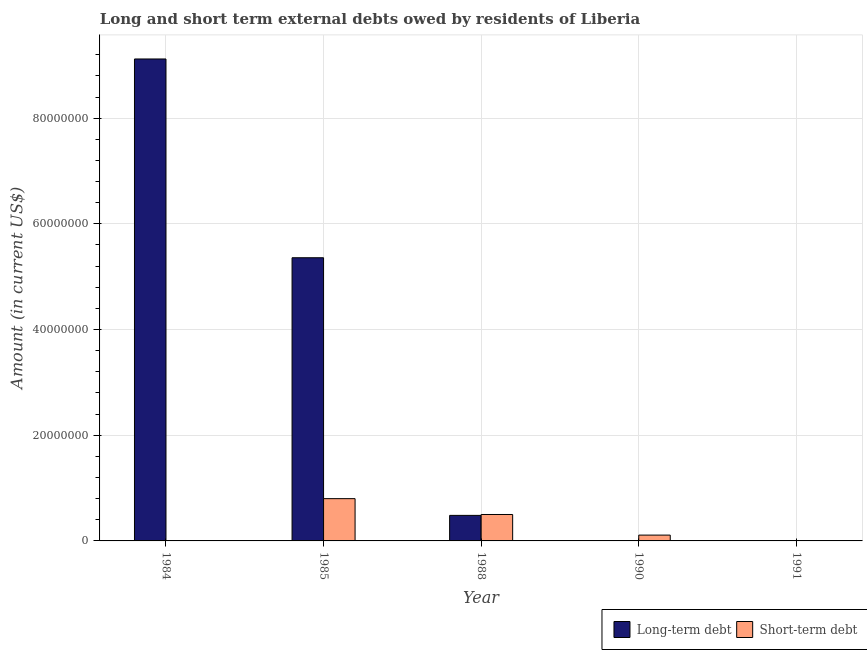How many different coloured bars are there?
Provide a succinct answer. 2. Are the number of bars per tick equal to the number of legend labels?
Keep it short and to the point. No. Are the number of bars on each tick of the X-axis equal?
Offer a very short reply. No. How many bars are there on the 3rd tick from the right?
Your response must be concise. 2. What is the label of the 3rd group of bars from the left?
Your response must be concise. 1988. What is the long-term debts owed by residents in 1984?
Ensure brevity in your answer.  9.12e+07. Across all years, what is the maximum long-term debts owed by residents?
Ensure brevity in your answer.  9.12e+07. Across all years, what is the minimum short-term debts owed by residents?
Ensure brevity in your answer.  0. In which year was the short-term debts owed by residents maximum?
Your answer should be compact. 1985. What is the total long-term debts owed by residents in the graph?
Make the answer very short. 1.50e+08. What is the difference between the long-term debts owed by residents in 1984 and that in 1988?
Provide a short and direct response. 8.64e+07. What is the difference between the long-term debts owed by residents in 1990 and the short-term debts owed by residents in 1991?
Ensure brevity in your answer.  0. What is the average long-term debts owed by residents per year?
Ensure brevity in your answer.  2.99e+07. In the year 1985, what is the difference between the short-term debts owed by residents and long-term debts owed by residents?
Offer a very short reply. 0. What is the ratio of the long-term debts owed by residents in 1984 to that in 1988?
Keep it short and to the point. 18.87. Is the short-term debts owed by residents in 1985 less than that in 1990?
Make the answer very short. No. Is the difference between the long-term debts owed by residents in 1984 and 1988 greater than the difference between the short-term debts owed by residents in 1984 and 1988?
Your answer should be very brief. No. What is the difference between the highest and the second highest long-term debts owed by residents?
Your answer should be compact. 3.76e+07. What is the difference between the highest and the lowest long-term debts owed by residents?
Make the answer very short. 9.12e+07. Is the sum of the short-term debts owed by residents in 1988 and 1990 greater than the maximum long-term debts owed by residents across all years?
Make the answer very short. No. Are all the bars in the graph horizontal?
Provide a short and direct response. No. Does the graph contain any zero values?
Your answer should be very brief. Yes. Where does the legend appear in the graph?
Offer a terse response. Bottom right. What is the title of the graph?
Give a very brief answer. Long and short term external debts owed by residents of Liberia. Does "From Government" appear as one of the legend labels in the graph?
Offer a very short reply. No. What is the label or title of the X-axis?
Ensure brevity in your answer.  Year. What is the label or title of the Y-axis?
Your response must be concise. Amount (in current US$). What is the Amount (in current US$) of Long-term debt in 1984?
Offer a terse response. 9.12e+07. What is the Amount (in current US$) of Long-term debt in 1985?
Offer a very short reply. 5.36e+07. What is the Amount (in current US$) of Short-term debt in 1985?
Your answer should be compact. 8.00e+06. What is the Amount (in current US$) in Long-term debt in 1988?
Your response must be concise. 4.83e+06. What is the Amount (in current US$) in Short-term debt in 1990?
Offer a very short reply. 1.10e+06. What is the Amount (in current US$) in Long-term debt in 1991?
Offer a very short reply. 0. What is the Amount (in current US$) in Short-term debt in 1991?
Ensure brevity in your answer.  0. Across all years, what is the maximum Amount (in current US$) in Long-term debt?
Offer a terse response. 9.12e+07. Across all years, what is the maximum Amount (in current US$) of Short-term debt?
Your response must be concise. 8.00e+06. What is the total Amount (in current US$) in Long-term debt in the graph?
Your response must be concise. 1.50e+08. What is the total Amount (in current US$) of Short-term debt in the graph?
Provide a succinct answer. 1.41e+07. What is the difference between the Amount (in current US$) of Long-term debt in 1984 and that in 1985?
Your response must be concise. 3.76e+07. What is the difference between the Amount (in current US$) in Long-term debt in 1984 and that in 1988?
Keep it short and to the point. 8.64e+07. What is the difference between the Amount (in current US$) in Long-term debt in 1985 and that in 1988?
Your answer should be very brief. 4.88e+07. What is the difference between the Amount (in current US$) in Short-term debt in 1985 and that in 1990?
Keep it short and to the point. 6.90e+06. What is the difference between the Amount (in current US$) of Short-term debt in 1988 and that in 1990?
Your answer should be very brief. 3.90e+06. What is the difference between the Amount (in current US$) in Long-term debt in 1984 and the Amount (in current US$) in Short-term debt in 1985?
Give a very brief answer. 8.32e+07. What is the difference between the Amount (in current US$) in Long-term debt in 1984 and the Amount (in current US$) in Short-term debt in 1988?
Provide a short and direct response. 8.62e+07. What is the difference between the Amount (in current US$) in Long-term debt in 1984 and the Amount (in current US$) in Short-term debt in 1990?
Offer a very short reply. 9.01e+07. What is the difference between the Amount (in current US$) of Long-term debt in 1985 and the Amount (in current US$) of Short-term debt in 1988?
Keep it short and to the point. 4.86e+07. What is the difference between the Amount (in current US$) in Long-term debt in 1985 and the Amount (in current US$) in Short-term debt in 1990?
Offer a very short reply. 5.25e+07. What is the difference between the Amount (in current US$) of Long-term debt in 1988 and the Amount (in current US$) of Short-term debt in 1990?
Your answer should be very brief. 3.73e+06. What is the average Amount (in current US$) of Long-term debt per year?
Your answer should be very brief. 2.99e+07. What is the average Amount (in current US$) in Short-term debt per year?
Provide a succinct answer. 2.82e+06. In the year 1985, what is the difference between the Amount (in current US$) in Long-term debt and Amount (in current US$) in Short-term debt?
Your answer should be very brief. 4.56e+07. In the year 1988, what is the difference between the Amount (in current US$) in Long-term debt and Amount (in current US$) in Short-term debt?
Give a very brief answer. -1.66e+05. What is the ratio of the Amount (in current US$) of Long-term debt in 1984 to that in 1985?
Offer a terse response. 1.7. What is the ratio of the Amount (in current US$) of Long-term debt in 1984 to that in 1988?
Offer a very short reply. 18.87. What is the ratio of the Amount (in current US$) of Long-term debt in 1985 to that in 1988?
Give a very brief answer. 11.09. What is the ratio of the Amount (in current US$) in Short-term debt in 1985 to that in 1988?
Offer a terse response. 1.6. What is the ratio of the Amount (in current US$) of Short-term debt in 1985 to that in 1990?
Your answer should be very brief. 7.27. What is the ratio of the Amount (in current US$) of Short-term debt in 1988 to that in 1990?
Ensure brevity in your answer.  4.55. What is the difference between the highest and the second highest Amount (in current US$) of Long-term debt?
Give a very brief answer. 3.76e+07. What is the difference between the highest and the second highest Amount (in current US$) in Short-term debt?
Ensure brevity in your answer.  3.00e+06. What is the difference between the highest and the lowest Amount (in current US$) of Long-term debt?
Your answer should be very brief. 9.12e+07. What is the difference between the highest and the lowest Amount (in current US$) of Short-term debt?
Your answer should be very brief. 8.00e+06. 